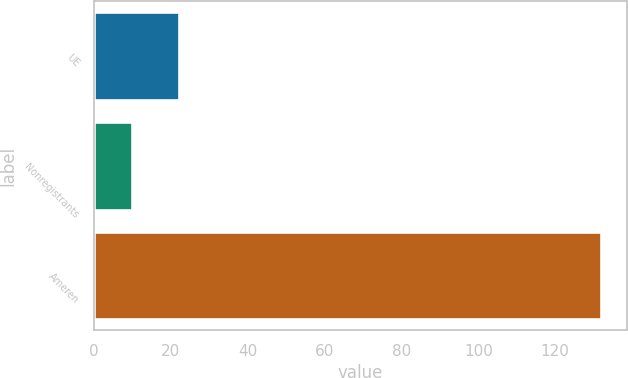<chart> <loc_0><loc_0><loc_500><loc_500><bar_chart><fcel>UE<fcel>Nonregistrants<fcel>Ameren<nl><fcel>22.2<fcel>10<fcel>132<nl></chart> 